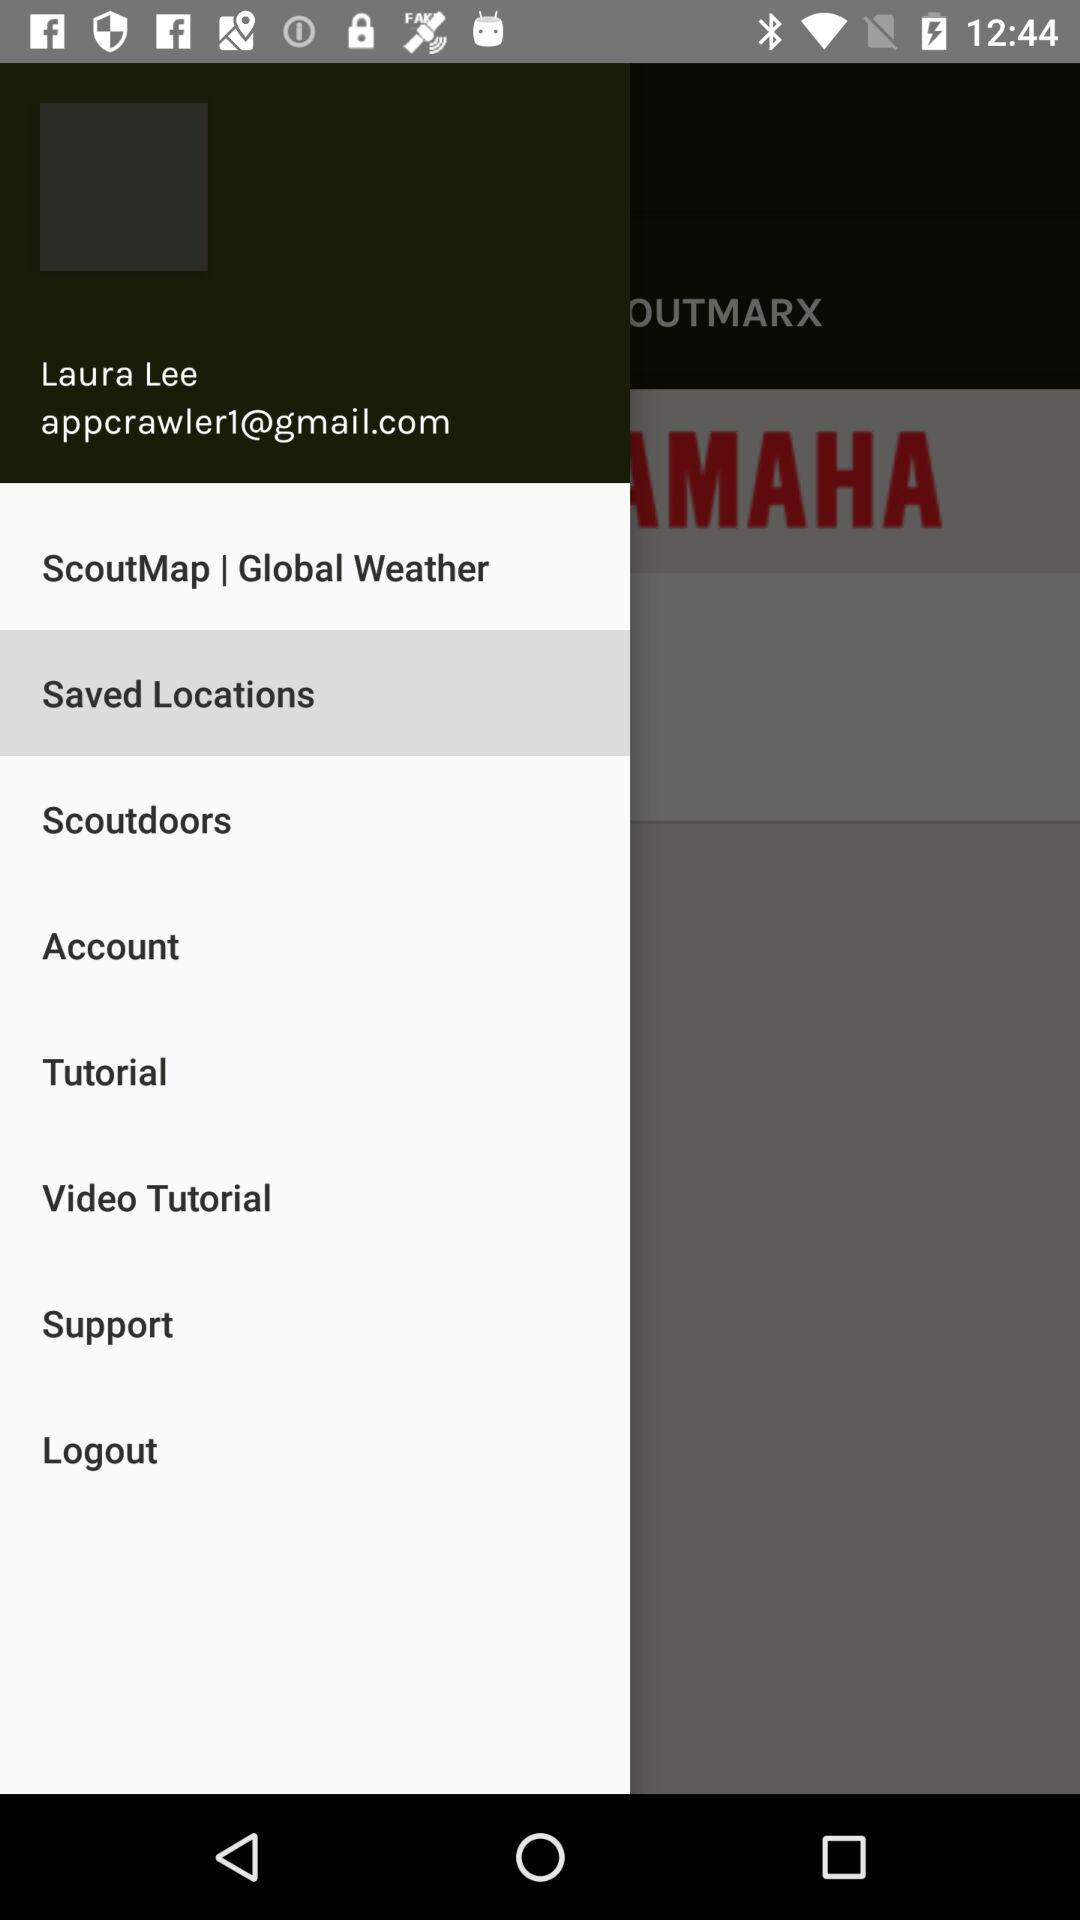What is the email address? The email address is appcrawler1@gmail.com. 